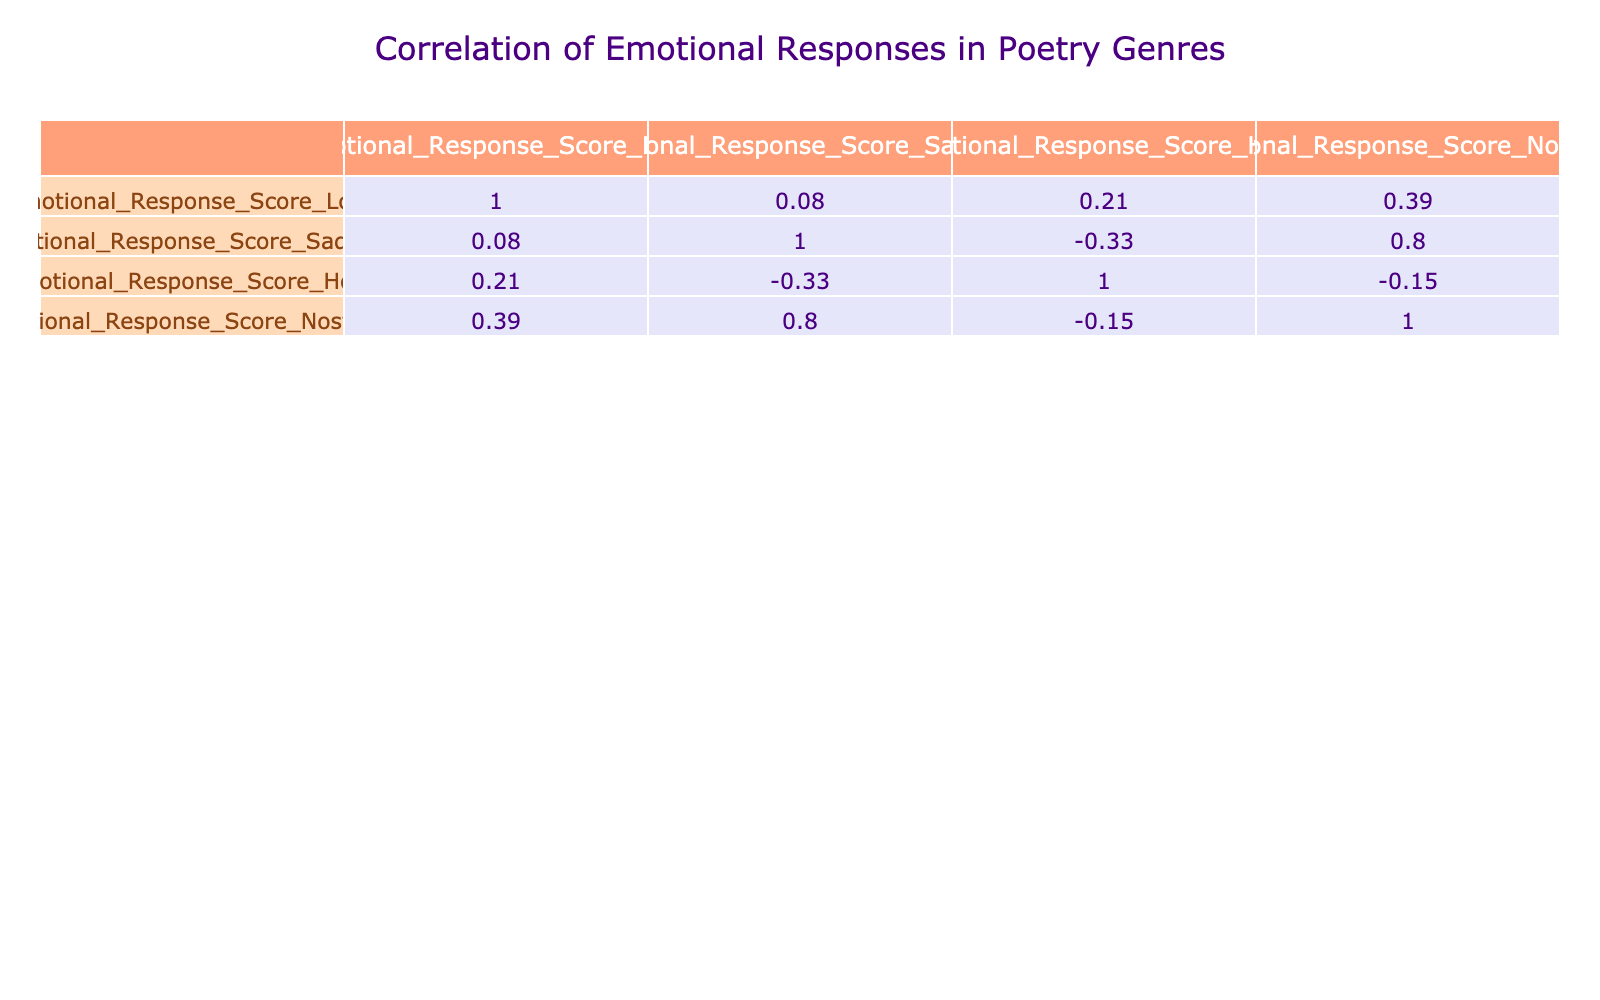What is the emotional response score for the Sonnet in Love? The table indicates the emotional response score for the Sonnet genre specifically in the Love category is listed directly in the corresponding row, which is 8.
Answer: 8 Which poetry genre has the highest emotional response score for Sadness? By examining the table, the emotional response scores in the Sadness column must be reviewed, and the highest score among these scores is 8, which corresponds to the Narrative genre.
Answer: Narrative What is the average emotional response score for Hope across all genres? The scores for Hope need to be averaged. The total for Hope is calculated by adding the values (7 + 9 + 8 + 6 + 5 + 9 + 7 + 6) = 57 and then dividing by the number of genres, which is 8. Therefore, 57/8 equals 7.125.
Answer: 7.125 Is there a clear correlation between emotional responses of Nostalgia and Sadness? To determine if there is correlation, we look at the values for both Nostalgia and Sadness. The scores don't show a direct correlation, as we see varied results across genres, making a correlation unlikely based on the given data.
Answer: No What is the difference in emotional response scores for Love between Ode and Limerick? The score for Ode in Love is 9, and for Limerick, it is 5. To find the difference, we subtract Limerick's score from Ode's score: 9 - 5 equals 4.
Answer: 4 Which genre has the most varied emotional response scores when considering all four emotional categories? To assess variability, we look at the range within each genre (the difference between the highest and lowest scores). Analyzing the scores, the Sonnet shows a spread from 4 to 9, which is a wide range, leading to the conclusion that Sonnet has the highest variability.
Answer: Sonnet Does the Ballad genre evoke more Hope or Nostalgia? Directly comparing the scores for the Ballad genre, we see the score for Hope is 5 and for Nostalgia it is 8. Therefore, the Ballad evokes more Nostalgia than Hope.
Answer: Nostalgia What is the emotional response score for Free Verse in Nostalgia? The score for Free Verse in the Nostalgia category is read directly from the table, which indicates a score of 8.
Answer: 8 Which poetry genre has the lowest emotional response score for Love? By reviewing the table, we notice that the lowest score in the Love category is 5, which corresponds to the Limerick genre.
Answer: Limerick 